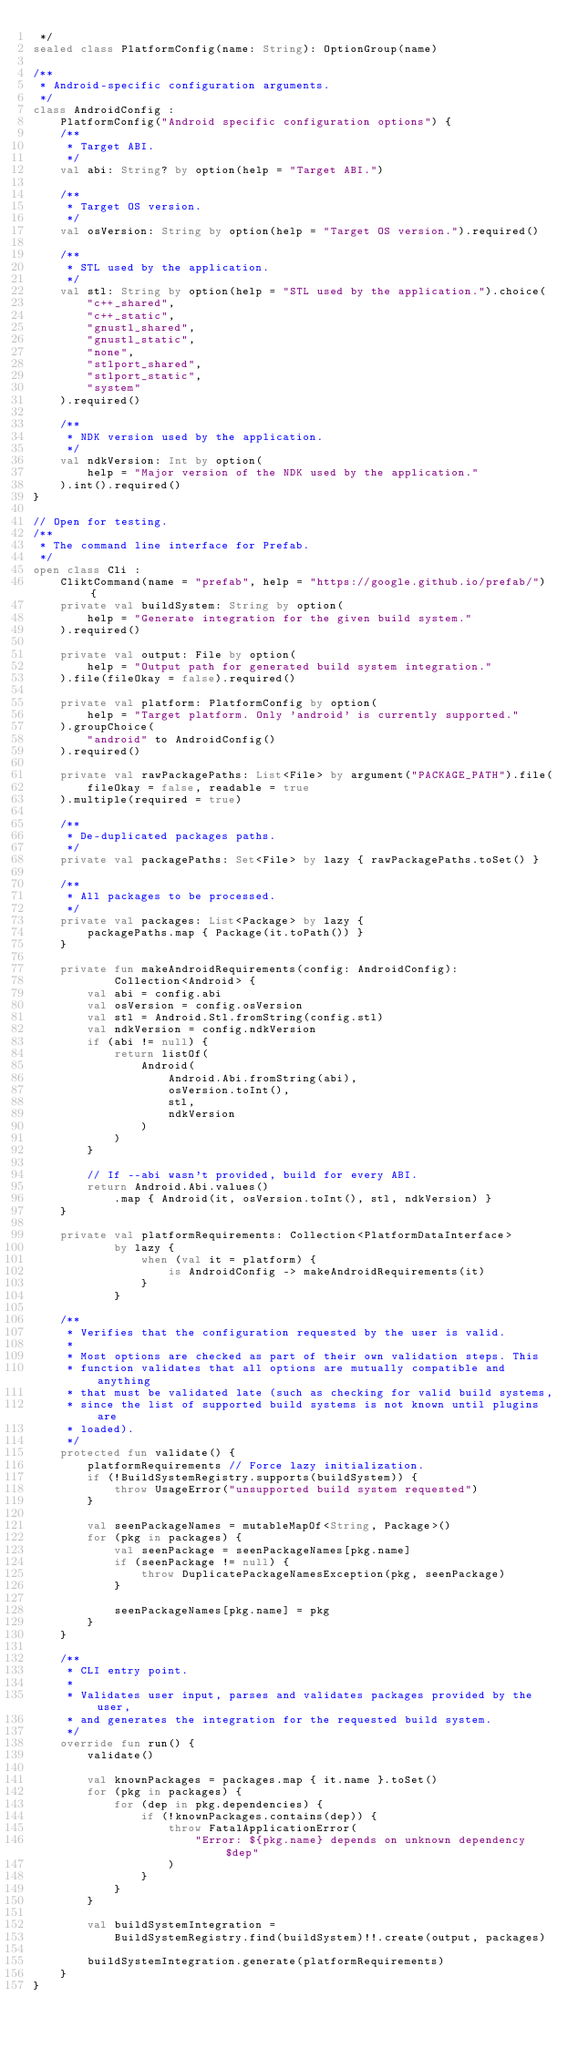<code> <loc_0><loc_0><loc_500><loc_500><_Kotlin_> */
sealed class PlatformConfig(name: String): OptionGroup(name)

/**
 * Android-specific configuration arguments.
 */
class AndroidConfig :
    PlatformConfig("Android specific configuration options") {
    /**
     * Target ABI.
     */
    val abi: String? by option(help = "Target ABI.")

    /**
     * Target OS version.
     */
    val osVersion: String by option(help = "Target OS version.").required()

    /**
     * STL used by the application.
     */
    val stl: String by option(help = "STL used by the application.").choice(
        "c++_shared",
        "c++_static",
        "gnustl_shared",
        "gnustl_static",
        "none",
        "stlport_shared",
        "stlport_static",
        "system"
    ).required()

    /**
     * NDK version used by the application.
     */
    val ndkVersion: Int by option(
        help = "Major version of the NDK used by the application."
    ).int().required()
}

// Open for testing.
/**
 * The command line interface for Prefab.
 */
open class Cli :
    CliktCommand(name = "prefab", help = "https://google.github.io/prefab/") {
    private val buildSystem: String by option(
        help = "Generate integration for the given build system."
    ).required()

    private val output: File by option(
        help = "Output path for generated build system integration."
    ).file(fileOkay = false).required()

    private val platform: PlatformConfig by option(
        help = "Target platform. Only 'android' is currently supported."
    ).groupChoice(
        "android" to AndroidConfig()
    ).required()

    private val rawPackagePaths: List<File> by argument("PACKAGE_PATH").file(
        fileOkay = false, readable = true
    ).multiple(required = true)

    /**
     * De-duplicated packages paths.
     */
    private val packagePaths: Set<File> by lazy { rawPackagePaths.toSet() }

    /**
     * All packages to be processed.
     */
    private val packages: List<Package> by lazy {
        packagePaths.map { Package(it.toPath()) }
    }

    private fun makeAndroidRequirements(config: AndroidConfig):
            Collection<Android> {
        val abi = config.abi
        val osVersion = config.osVersion
        val stl = Android.Stl.fromString(config.stl)
        val ndkVersion = config.ndkVersion
        if (abi != null) {
            return listOf(
                Android(
                    Android.Abi.fromString(abi),
                    osVersion.toInt(),
                    stl,
                    ndkVersion
                )
            )
        }

        // If --abi wasn't provided, build for every ABI.
        return Android.Abi.values()
            .map { Android(it, osVersion.toInt(), stl, ndkVersion) }
    }

    private val platformRequirements: Collection<PlatformDataInterface>
            by lazy {
                when (val it = platform) {
                    is AndroidConfig -> makeAndroidRequirements(it)
                }
            }

    /**
     * Verifies that the configuration requested by the user is valid.
     *
     * Most options are checked as part of their own validation steps. This
     * function validates that all options are mutually compatible and anything
     * that must be validated late (such as checking for valid build systems,
     * since the list of supported build systems is not known until plugins are
     * loaded).
     */
    protected fun validate() {
        platformRequirements // Force lazy initialization.
        if (!BuildSystemRegistry.supports(buildSystem)) {
            throw UsageError("unsupported build system requested")
        }

        val seenPackageNames = mutableMapOf<String, Package>()
        for (pkg in packages) {
            val seenPackage = seenPackageNames[pkg.name]
            if (seenPackage != null) {
                throw DuplicatePackageNamesException(pkg, seenPackage)
            }

            seenPackageNames[pkg.name] = pkg
        }
    }

    /**
     * CLI entry point.
     *
     * Validates user input, parses and validates packages provided by the user,
     * and generates the integration for the requested build system.
     */
    override fun run() {
        validate()

        val knownPackages = packages.map { it.name }.toSet()
        for (pkg in packages) {
            for (dep in pkg.dependencies) {
                if (!knownPackages.contains(dep)) {
                    throw FatalApplicationError(
                        "Error: ${pkg.name} depends on unknown dependency $dep"
                    )
                }
            }
        }

        val buildSystemIntegration =
            BuildSystemRegistry.find(buildSystem)!!.create(output, packages)

        buildSystemIntegration.generate(platformRequirements)
    }
}
</code> 